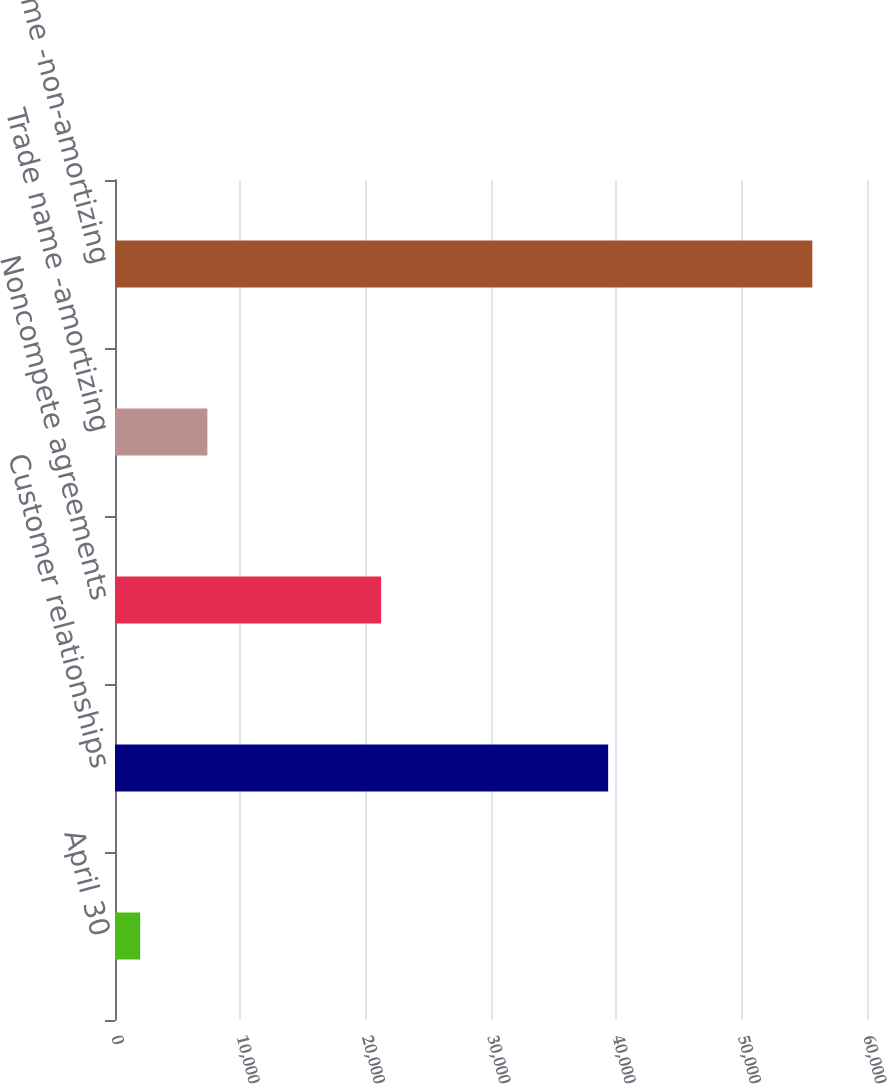<chart> <loc_0><loc_0><loc_500><loc_500><bar_chart><fcel>April 30<fcel>Customer relationships<fcel>Noncompete agreements<fcel>Trade name -amortizing<fcel>Trade name -non-amortizing<nl><fcel>2007<fcel>39347<fcel>21237<fcel>7370<fcel>55637<nl></chart> 